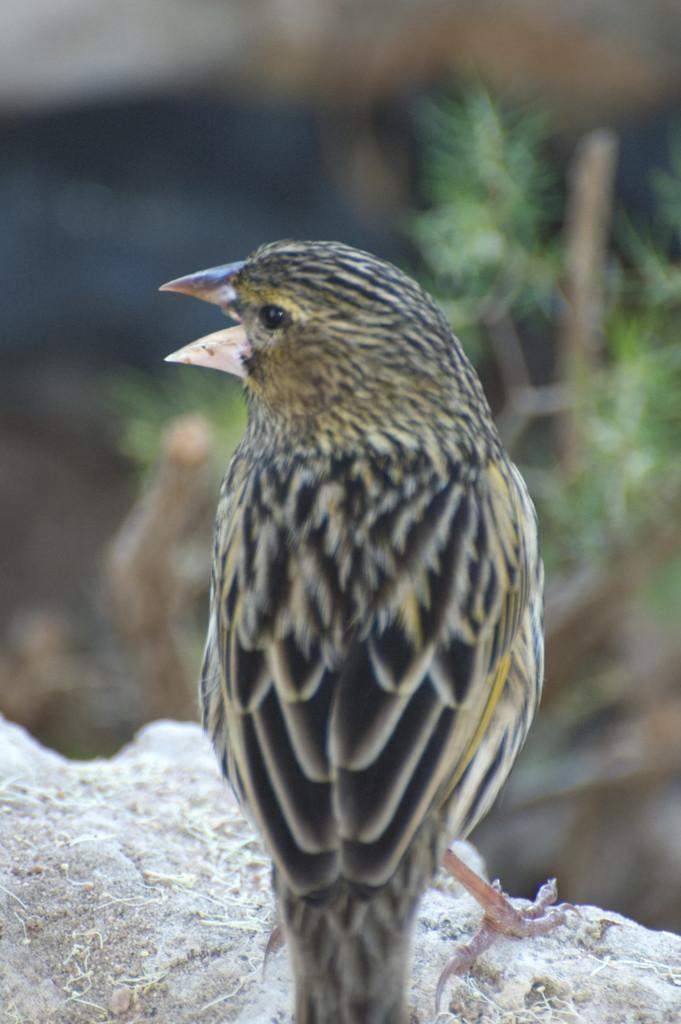What type of animal can be seen in the image? There is a bird in the image. What can be seen in the background of the image? There is a plant in the background of the image. What type of muscle is visible on the bird in the image? There is no specific muscle visible on the bird in the image; it is a general representation of a bird. 